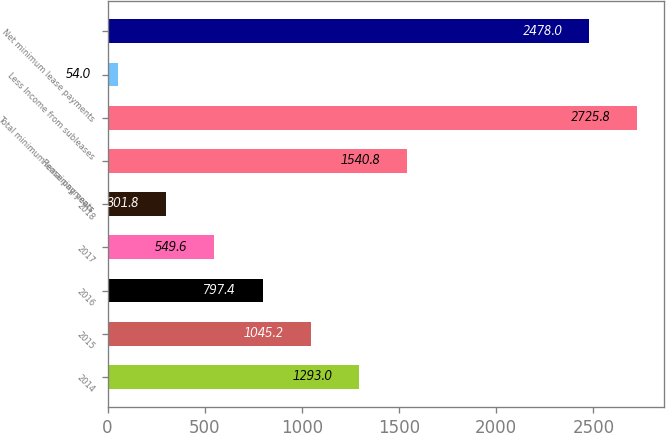Convert chart. <chart><loc_0><loc_0><loc_500><loc_500><bar_chart><fcel>2014<fcel>2015<fcel>2016<fcel>2017<fcel>2018<fcel>Remaining years<fcel>Total minimum lease payments<fcel>Less Income from subleases<fcel>Net minimum lease payments<nl><fcel>1293<fcel>1045.2<fcel>797.4<fcel>549.6<fcel>301.8<fcel>1540.8<fcel>2725.8<fcel>54<fcel>2478<nl></chart> 